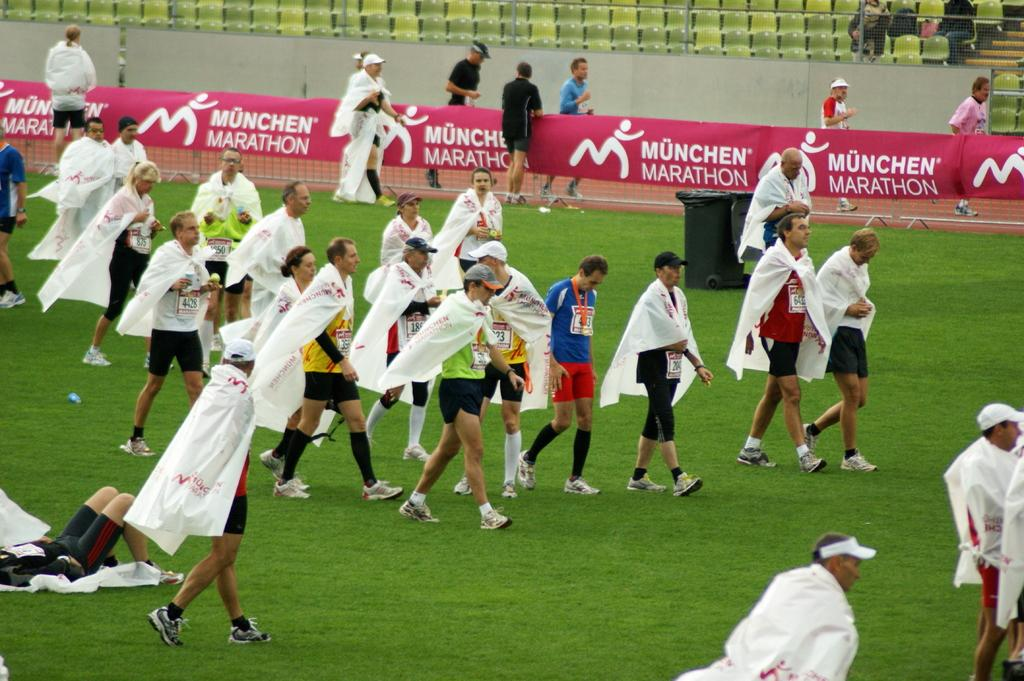<image>
Create a compact narrative representing the image presented. People wearing white sheets with Munchen Marathon in the background 